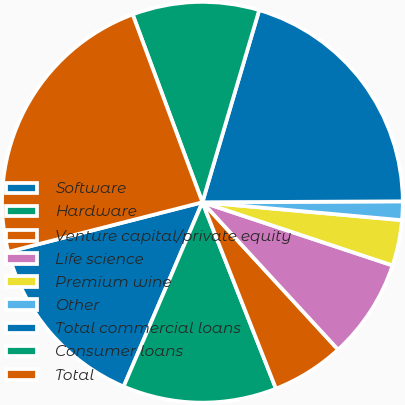Convert chart. <chart><loc_0><loc_0><loc_500><loc_500><pie_chart><fcel>Software<fcel>Hardware<fcel>Venture capital/private equity<fcel>Life science<fcel>Premium wine<fcel>Other<fcel>Total commercial loans<fcel>Consumer loans<fcel>Total<nl><fcel>14.59%<fcel>12.41%<fcel>5.86%<fcel>8.05%<fcel>3.68%<fcel>1.5%<fcel>20.35%<fcel>10.23%<fcel>23.32%<nl></chart> 